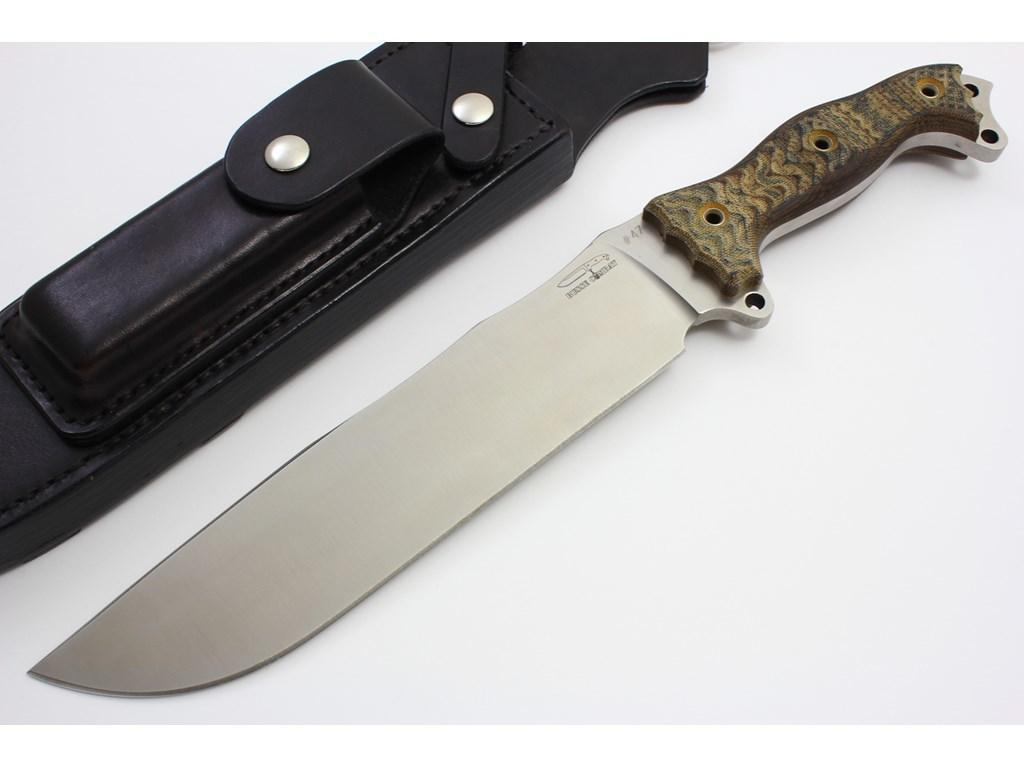What object can be seen in the image that is typically used for cutting? There is a knife in the image. What object is present in the image that can be used to cover something? There is a cover in the image. On what surface are the knife and cover placed in the image? The knife and cover are placed on a white surface in the image. What type of coach is present in the image? There is no coach present in the image; it only features a knife and a cover placed on a white surface. 